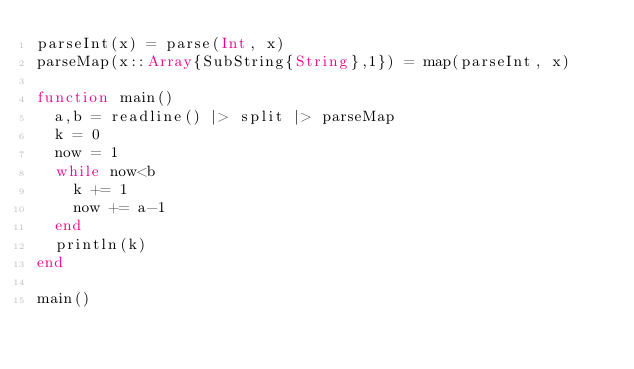<code> <loc_0><loc_0><loc_500><loc_500><_Julia_>parseInt(x) = parse(Int, x)
parseMap(x::Array{SubString{String},1}) = map(parseInt, x)

function main()
	a,b = readline() |> split |> parseMap
	k = 0
	now = 1
	while now<b
		k += 1
		now += a-1
	end
	println(k)
end

main()</code> 